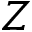Convert formula to latex. <formula><loc_0><loc_0><loc_500><loc_500>Z</formula> 